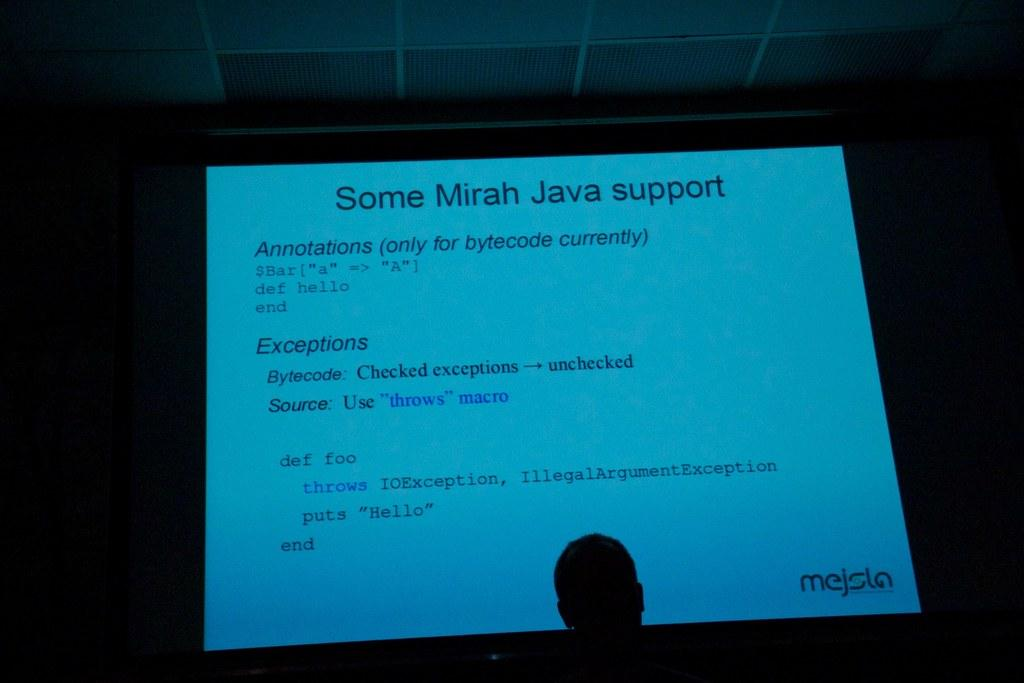What is the main object in the image? There is a screen in the image. Can you describe the person's position in relation to the screen? There is a person in front of the screen. What month does the person in the image experience a loss? There is no information about a loss or a specific month in the image. 